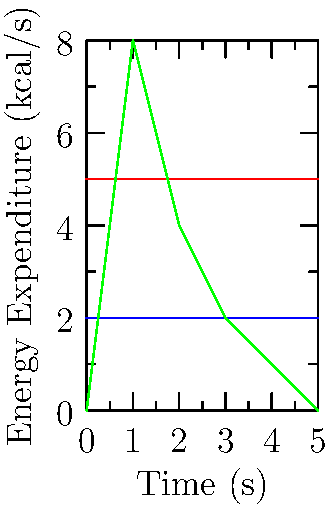In your upcoming emotionally immersive storytelling game, you want to calculate the total energy expenditure of a character during a 5-second gameplay sequence. The character walks for 2 seconds, runs for 1 second, and performs a jump that lasts 2 seconds. Using the energy expenditure rates shown in the graph for each activity, what is the total energy expended by the character during this sequence? To solve this problem, we need to calculate the energy expended during each activity and sum them up:

1. Walking (2 seconds):
   Energy rate for walking = 2 kcal/s
   Energy expended = 2 kcal/s * 2 s = 4 kcal

2. Running (1 second):
   Energy rate for running = 5 kcal/s
   Energy expended = 5 kcal/s * 1 s = 5 kcal

3. Jumping (2 seconds):
   For jumping, we need to calculate the area under the curve.
   The curve approximates a triangle with a base of 2 seconds and a height of 8 kcal/s.
   Area of a triangle = $\frac{1}{2}$ * base * height
   Energy expended = $\frac{1}{2}$ * 2 s * 8 kcal/s = 8 kcal

Total energy expended:
$$ \text{Total Energy} = \text{Walking} + \text{Running} + \text{Jumping} $$
$$ \text{Total Energy} = 4 \text{ kcal} + 5 \text{ kcal} + 8 \text{ kcal} = 17 \text{ kcal} $$
Answer: 17 kcal 